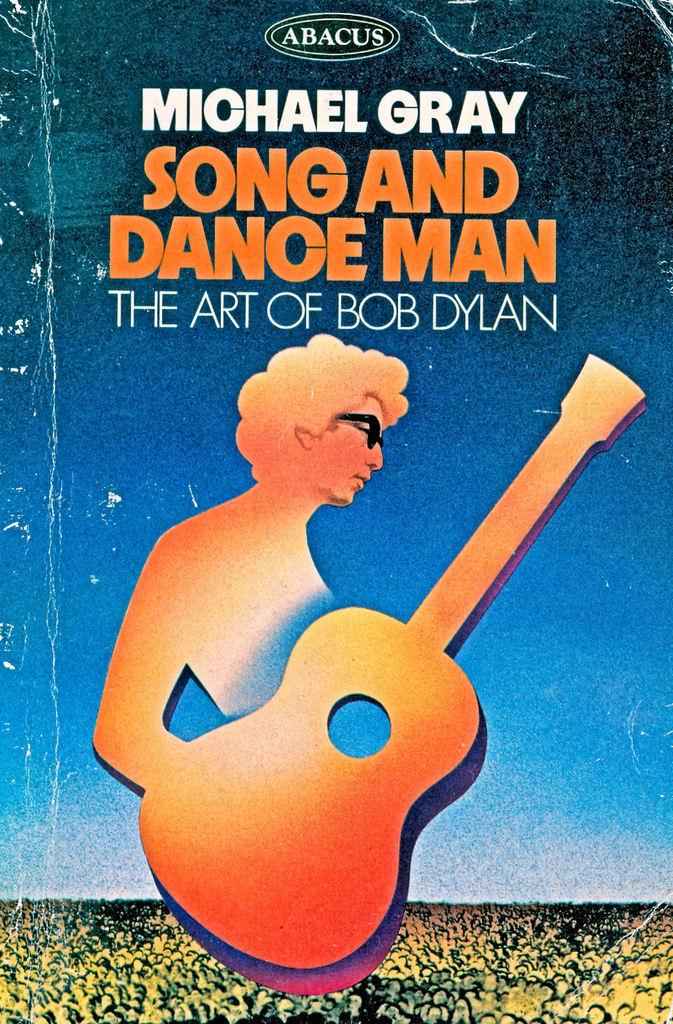<image>
Summarize the visual content of the image. Cover of Bob Dylan booklet showing a man holding an orange guitar on the cover. 